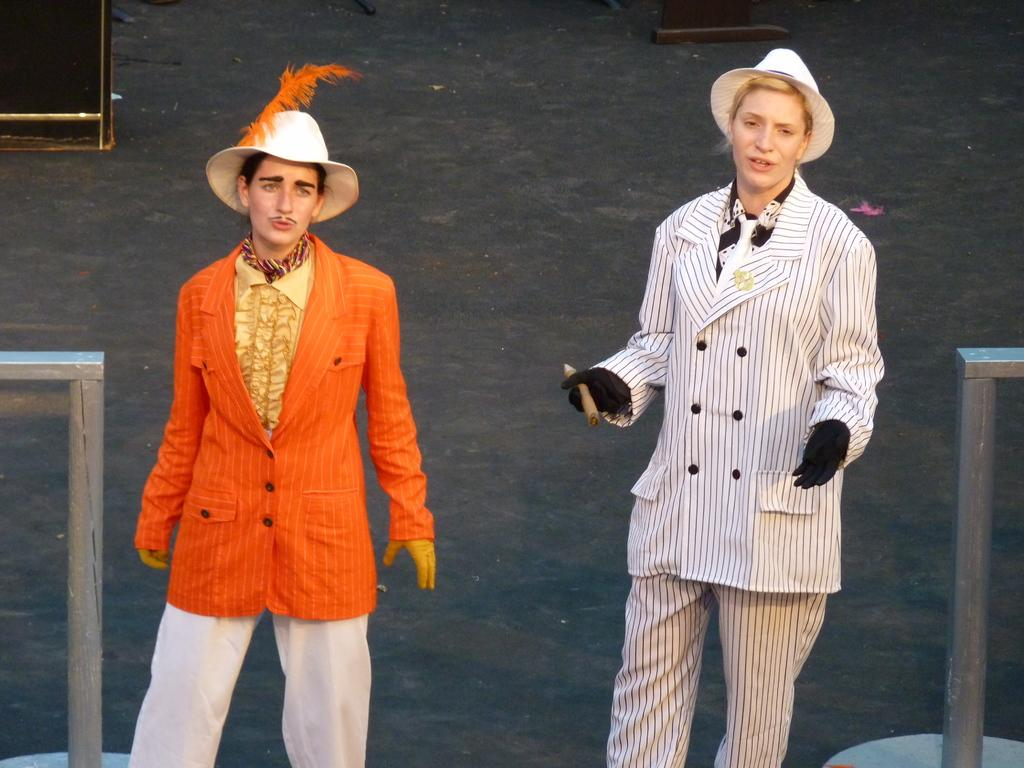What are the two people in the image wearing? The two people in the image are wearing costumes. Can you describe the stands in the image? There are two stands, one on the right side and one on the left side of the image. What else can be seen in the background of the image? There are other objects visible in the background of the image. How does the uncle taste the food in the image? There is no uncle present in the image, so it is not possible to answer that question. 